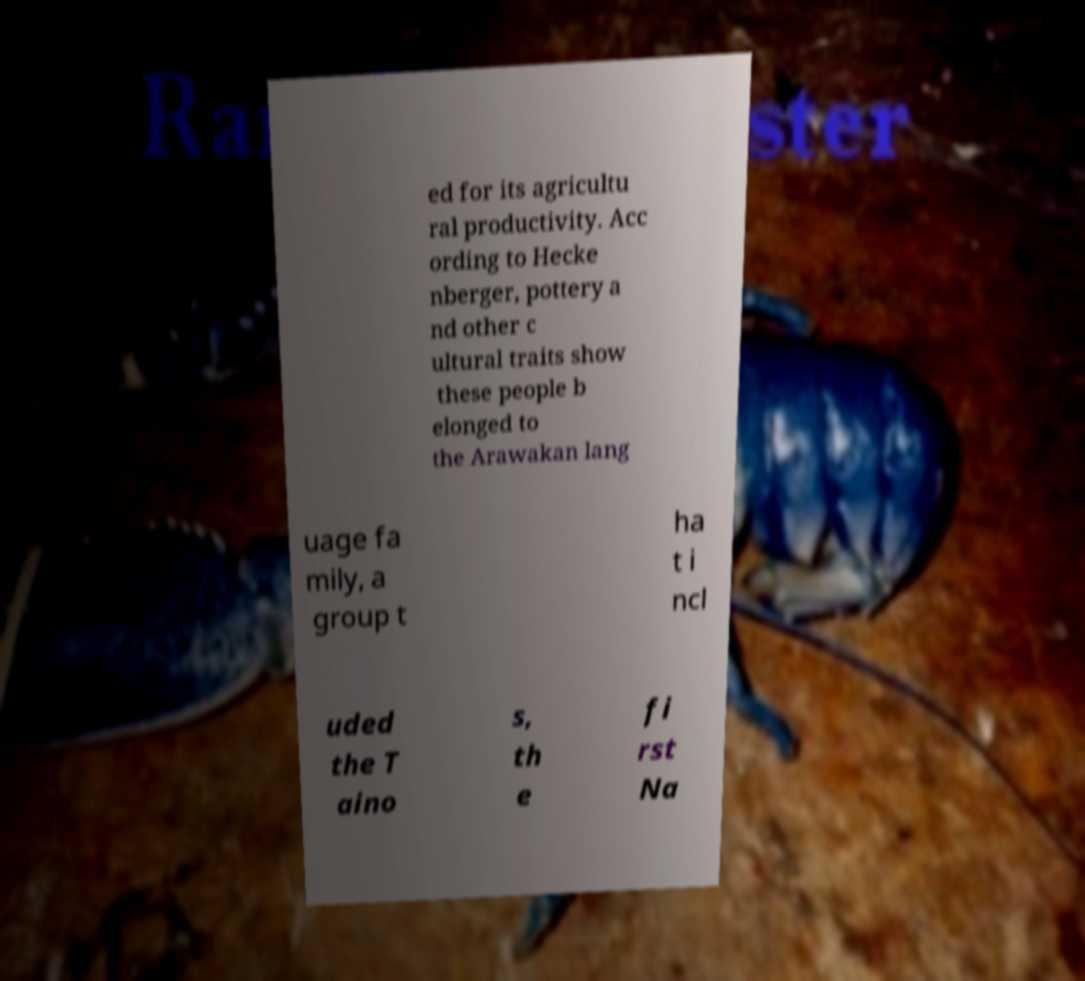I need the written content from this picture converted into text. Can you do that? ed for its agricultu ral productivity. Acc ording to Hecke nberger, pottery a nd other c ultural traits show these people b elonged to the Arawakan lang uage fa mily, a group t ha t i ncl uded the T aino s, th e fi rst Na 